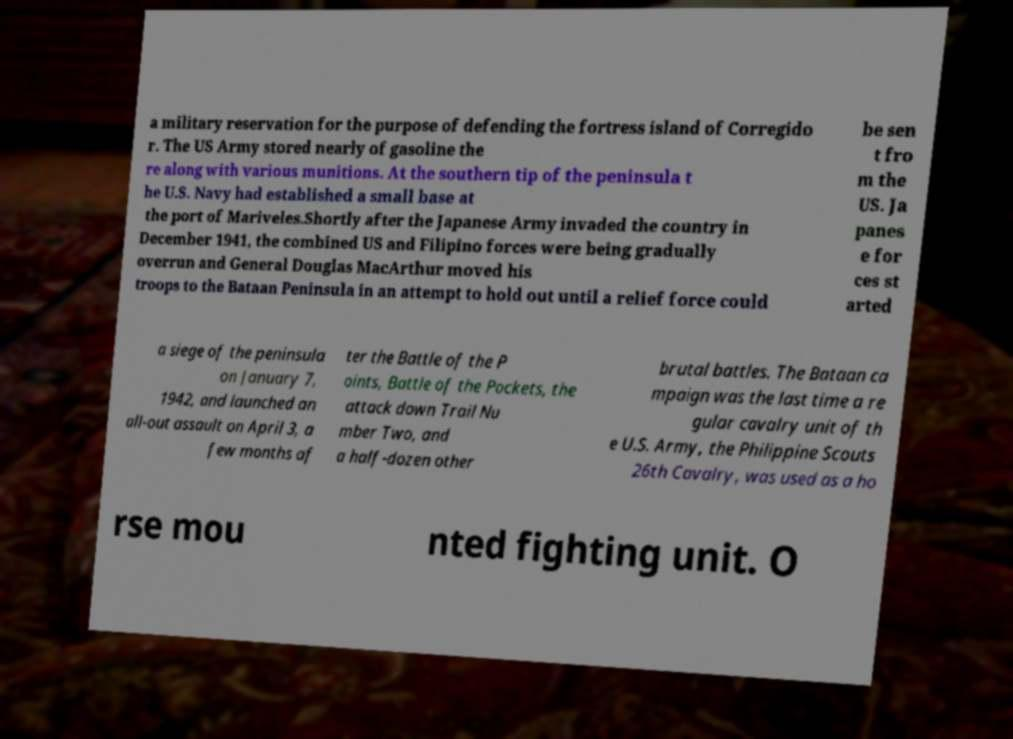Could you extract and type out the text from this image? a military reservation for the purpose of defending the fortress island of Corregido r. The US Army stored nearly of gasoline the re along with various munitions. At the southern tip of the peninsula t he U.S. Navy had established a small base at the port of Mariveles.Shortly after the Japanese Army invaded the country in December 1941, the combined US and Filipino forces were being gradually overrun and General Douglas MacArthur moved his troops to the Bataan Peninsula in an attempt to hold out until a relief force could be sen t fro m the US. Ja panes e for ces st arted a siege of the peninsula on January 7, 1942, and launched an all-out assault on April 3, a few months af ter the Battle of the P oints, Battle of the Pockets, the attack down Trail Nu mber Two, and a half-dozen other brutal battles. The Bataan ca mpaign was the last time a re gular cavalry unit of th e U.S. Army, the Philippine Scouts 26th Cavalry, was used as a ho rse mou nted fighting unit. O 